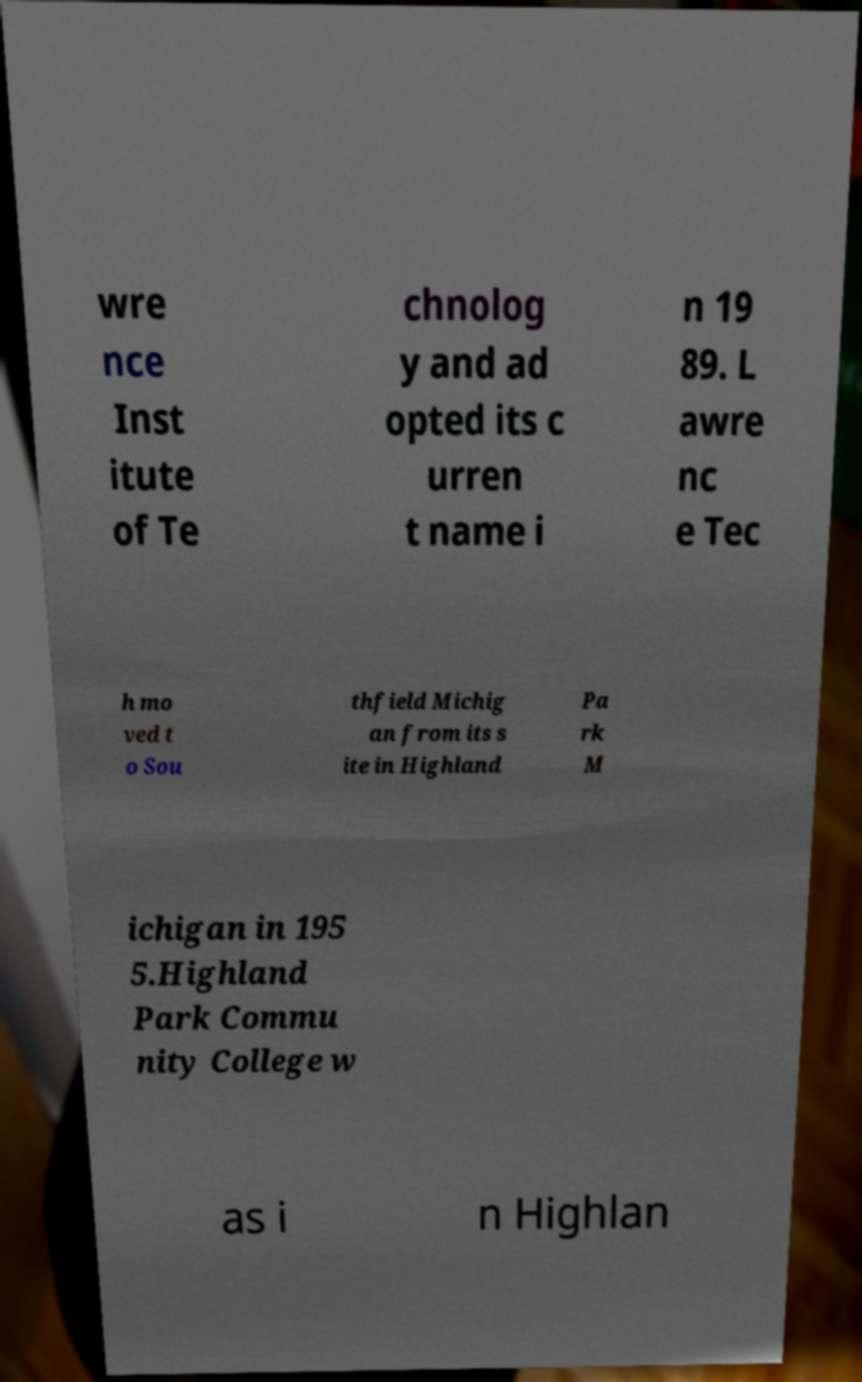Please read and relay the text visible in this image. What does it say? wre nce Inst itute of Te chnolog y and ad opted its c urren t name i n 19 89. L awre nc e Tec h mo ved t o Sou thfield Michig an from its s ite in Highland Pa rk M ichigan in 195 5.Highland Park Commu nity College w as i n Highlan 